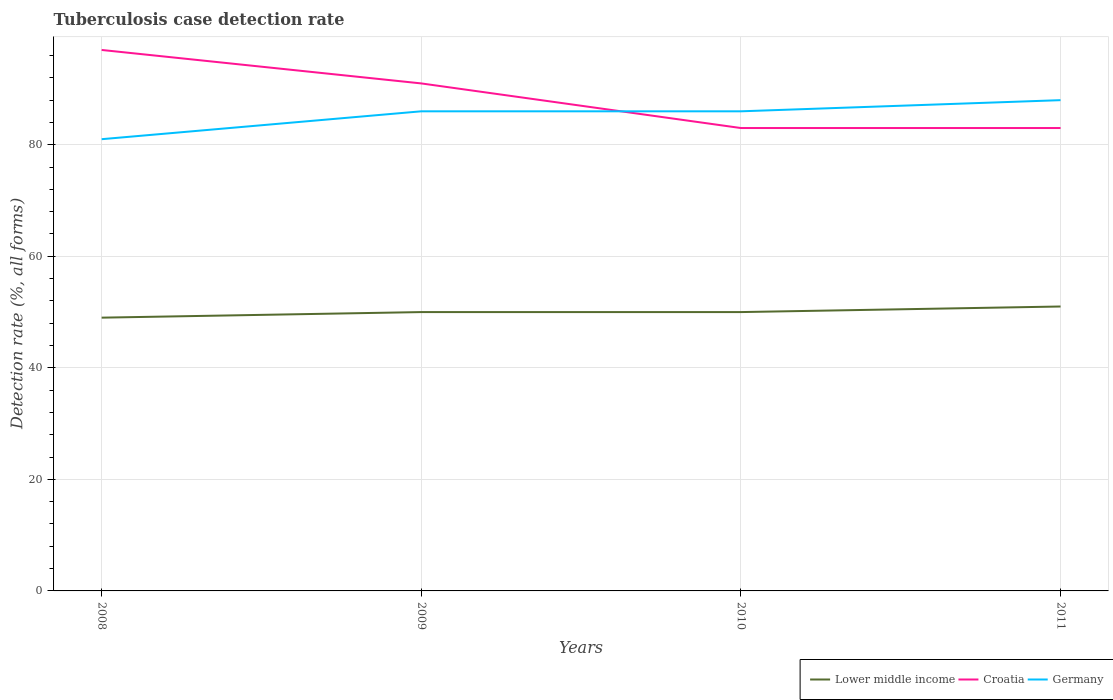Does the line corresponding to Croatia intersect with the line corresponding to Lower middle income?
Offer a very short reply. No. Across all years, what is the maximum tuberculosis case detection rate in in Germany?
Offer a terse response. 81. What is the total tuberculosis case detection rate in in Lower middle income in the graph?
Make the answer very short. 0. What is the difference between the highest and the second highest tuberculosis case detection rate in in Croatia?
Give a very brief answer. 14. What is the difference between the highest and the lowest tuberculosis case detection rate in in Lower middle income?
Offer a terse response. 1. How many lines are there?
Give a very brief answer. 3. How many years are there in the graph?
Your response must be concise. 4. What is the difference between two consecutive major ticks on the Y-axis?
Keep it short and to the point. 20. Are the values on the major ticks of Y-axis written in scientific E-notation?
Ensure brevity in your answer.  No. Does the graph contain any zero values?
Make the answer very short. No. How are the legend labels stacked?
Offer a terse response. Horizontal. What is the title of the graph?
Give a very brief answer. Tuberculosis case detection rate. What is the label or title of the Y-axis?
Provide a short and direct response. Detection rate (%, all forms). What is the Detection rate (%, all forms) of Lower middle income in 2008?
Offer a very short reply. 49. What is the Detection rate (%, all forms) of Croatia in 2008?
Keep it short and to the point. 97. What is the Detection rate (%, all forms) in Lower middle income in 2009?
Your answer should be compact. 50. What is the Detection rate (%, all forms) in Croatia in 2009?
Make the answer very short. 91. What is the Detection rate (%, all forms) in Germany in 2009?
Provide a succinct answer. 86. What is the Detection rate (%, all forms) in Lower middle income in 2010?
Keep it short and to the point. 50. What is the Detection rate (%, all forms) in Croatia in 2010?
Offer a terse response. 83. What is the Detection rate (%, all forms) in Germany in 2010?
Your response must be concise. 86. What is the Detection rate (%, all forms) of Croatia in 2011?
Ensure brevity in your answer.  83. Across all years, what is the maximum Detection rate (%, all forms) in Croatia?
Your response must be concise. 97. Across all years, what is the minimum Detection rate (%, all forms) of Germany?
Your answer should be very brief. 81. What is the total Detection rate (%, all forms) of Croatia in the graph?
Your response must be concise. 354. What is the total Detection rate (%, all forms) in Germany in the graph?
Give a very brief answer. 341. What is the difference between the Detection rate (%, all forms) of Germany in 2008 and that in 2009?
Offer a terse response. -5. What is the difference between the Detection rate (%, all forms) of Germany in 2008 and that in 2011?
Make the answer very short. -7. What is the difference between the Detection rate (%, all forms) of Lower middle income in 2009 and that in 2010?
Offer a terse response. 0. What is the difference between the Detection rate (%, all forms) of Germany in 2009 and that in 2010?
Keep it short and to the point. 0. What is the difference between the Detection rate (%, all forms) of Croatia in 2009 and that in 2011?
Your response must be concise. 8. What is the difference between the Detection rate (%, all forms) in Germany in 2009 and that in 2011?
Provide a short and direct response. -2. What is the difference between the Detection rate (%, all forms) of Croatia in 2010 and that in 2011?
Your answer should be very brief. 0. What is the difference between the Detection rate (%, all forms) in Germany in 2010 and that in 2011?
Your answer should be very brief. -2. What is the difference between the Detection rate (%, all forms) of Lower middle income in 2008 and the Detection rate (%, all forms) of Croatia in 2009?
Give a very brief answer. -42. What is the difference between the Detection rate (%, all forms) of Lower middle income in 2008 and the Detection rate (%, all forms) of Germany in 2009?
Keep it short and to the point. -37. What is the difference between the Detection rate (%, all forms) in Lower middle income in 2008 and the Detection rate (%, all forms) in Croatia in 2010?
Your answer should be very brief. -34. What is the difference between the Detection rate (%, all forms) in Lower middle income in 2008 and the Detection rate (%, all forms) in Germany in 2010?
Make the answer very short. -37. What is the difference between the Detection rate (%, all forms) in Croatia in 2008 and the Detection rate (%, all forms) in Germany in 2010?
Offer a very short reply. 11. What is the difference between the Detection rate (%, all forms) in Lower middle income in 2008 and the Detection rate (%, all forms) in Croatia in 2011?
Make the answer very short. -34. What is the difference between the Detection rate (%, all forms) in Lower middle income in 2008 and the Detection rate (%, all forms) in Germany in 2011?
Make the answer very short. -39. What is the difference between the Detection rate (%, all forms) of Croatia in 2008 and the Detection rate (%, all forms) of Germany in 2011?
Offer a terse response. 9. What is the difference between the Detection rate (%, all forms) of Lower middle income in 2009 and the Detection rate (%, all forms) of Croatia in 2010?
Provide a succinct answer. -33. What is the difference between the Detection rate (%, all forms) of Lower middle income in 2009 and the Detection rate (%, all forms) of Germany in 2010?
Your answer should be compact. -36. What is the difference between the Detection rate (%, all forms) of Lower middle income in 2009 and the Detection rate (%, all forms) of Croatia in 2011?
Your answer should be compact. -33. What is the difference between the Detection rate (%, all forms) in Lower middle income in 2009 and the Detection rate (%, all forms) in Germany in 2011?
Offer a terse response. -38. What is the difference between the Detection rate (%, all forms) in Lower middle income in 2010 and the Detection rate (%, all forms) in Croatia in 2011?
Provide a succinct answer. -33. What is the difference between the Detection rate (%, all forms) in Lower middle income in 2010 and the Detection rate (%, all forms) in Germany in 2011?
Ensure brevity in your answer.  -38. What is the average Detection rate (%, all forms) of Lower middle income per year?
Offer a very short reply. 50. What is the average Detection rate (%, all forms) of Croatia per year?
Offer a very short reply. 88.5. What is the average Detection rate (%, all forms) in Germany per year?
Provide a short and direct response. 85.25. In the year 2008, what is the difference between the Detection rate (%, all forms) of Lower middle income and Detection rate (%, all forms) of Croatia?
Your answer should be very brief. -48. In the year 2008, what is the difference between the Detection rate (%, all forms) in Lower middle income and Detection rate (%, all forms) in Germany?
Your answer should be very brief. -32. In the year 2008, what is the difference between the Detection rate (%, all forms) of Croatia and Detection rate (%, all forms) of Germany?
Your response must be concise. 16. In the year 2009, what is the difference between the Detection rate (%, all forms) of Lower middle income and Detection rate (%, all forms) of Croatia?
Your response must be concise. -41. In the year 2009, what is the difference between the Detection rate (%, all forms) in Lower middle income and Detection rate (%, all forms) in Germany?
Ensure brevity in your answer.  -36. In the year 2009, what is the difference between the Detection rate (%, all forms) in Croatia and Detection rate (%, all forms) in Germany?
Offer a very short reply. 5. In the year 2010, what is the difference between the Detection rate (%, all forms) of Lower middle income and Detection rate (%, all forms) of Croatia?
Offer a terse response. -33. In the year 2010, what is the difference between the Detection rate (%, all forms) in Lower middle income and Detection rate (%, all forms) in Germany?
Your response must be concise. -36. In the year 2010, what is the difference between the Detection rate (%, all forms) of Croatia and Detection rate (%, all forms) of Germany?
Give a very brief answer. -3. In the year 2011, what is the difference between the Detection rate (%, all forms) in Lower middle income and Detection rate (%, all forms) in Croatia?
Your response must be concise. -32. In the year 2011, what is the difference between the Detection rate (%, all forms) of Lower middle income and Detection rate (%, all forms) of Germany?
Ensure brevity in your answer.  -37. In the year 2011, what is the difference between the Detection rate (%, all forms) in Croatia and Detection rate (%, all forms) in Germany?
Provide a short and direct response. -5. What is the ratio of the Detection rate (%, all forms) of Lower middle income in 2008 to that in 2009?
Offer a very short reply. 0.98. What is the ratio of the Detection rate (%, all forms) in Croatia in 2008 to that in 2009?
Provide a short and direct response. 1.07. What is the ratio of the Detection rate (%, all forms) of Germany in 2008 to that in 2009?
Ensure brevity in your answer.  0.94. What is the ratio of the Detection rate (%, all forms) of Lower middle income in 2008 to that in 2010?
Offer a terse response. 0.98. What is the ratio of the Detection rate (%, all forms) of Croatia in 2008 to that in 2010?
Your response must be concise. 1.17. What is the ratio of the Detection rate (%, all forms) in Germany in 2008 to that in 2010?
Give a very brief answer. 0.94. What is the ratio of the Detection rate (%, all forms) of Lower middle income in 2008 to that in 2011?
Make the answer very short. 0.96. What is the ratio of the Detection rate (%, all forms) in Croatia in 2008 to that in 2011?
Offer a very short reply. 1.17. What is the ratio of the Detection rate (%, all forms) in Germany in 2008 to that in 2011?
Make the answer very short. 0.92. What is the ratio of the Detection rate (%, all forms) of Lower middle income in 2009 to that in 2010?
Your response must be concise. 1. What is the ratio of the Detection rate (%, all forms) in Croatia in 2009 to that in 2010?
Make the answer very short. 1.1. What is the ratio of the Detection rate (%, all forms) of Germany in 2009 to that in 2010?
Give a very brief answer. 1. What is the ratio of the Detection rate (%, all forms) of Lower middle income in 2009 to that in 2011?
Your answer should be compact. 0.98. What is the ratio of the Detection rate (%, all forms) in Croatia in 2009 to that in 2011?
Provide a short and direct response. 1.1. What is the ratio of the Detection rate (%, all forms) of Germany in 2009 to that in 2011?
Your answer should be compact. 0.98. What is the ratio of the Detection rate (%, all forms) in Lower middle income in 2010 to that in 2011?
Make the answer very short. 0.98. What is the ratio of the Detection rate (%, all forms) of Croatia in 2010 to that in 2011?
Keep it short and to the point. 1. What is the ratio of the Detection rate (%, all forms) in Germany in 2010 to that in 2011?
Your answer should be very brief. 0.98. What is the difference between the highest and the second highest Detection rate (%, all forms) of Croatia?
Your answer should be very brief. 6. 